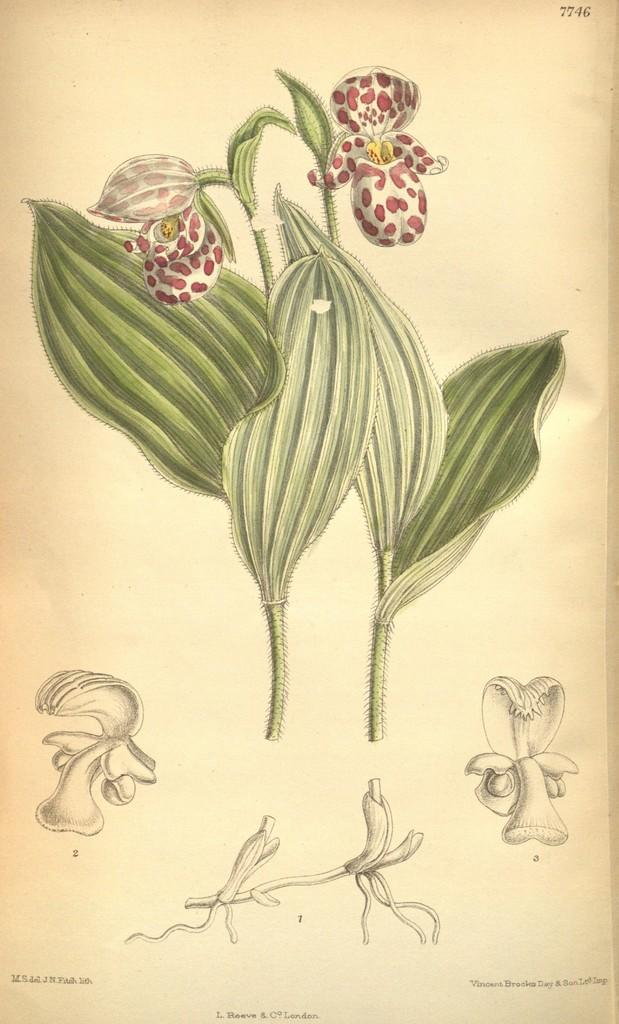What is depicted in the drawing in the image? There is a drawing of two plants in the image. What color are the flowers on the plants? The flowers on the plants are white. Are there any additional details about the flowers? Yes, the flowers have red dots on them. What type of agreement is being discussed in the image? There is no discussion or agreement present in the image; it features a drawing of two plants with white flowers and red dots. 